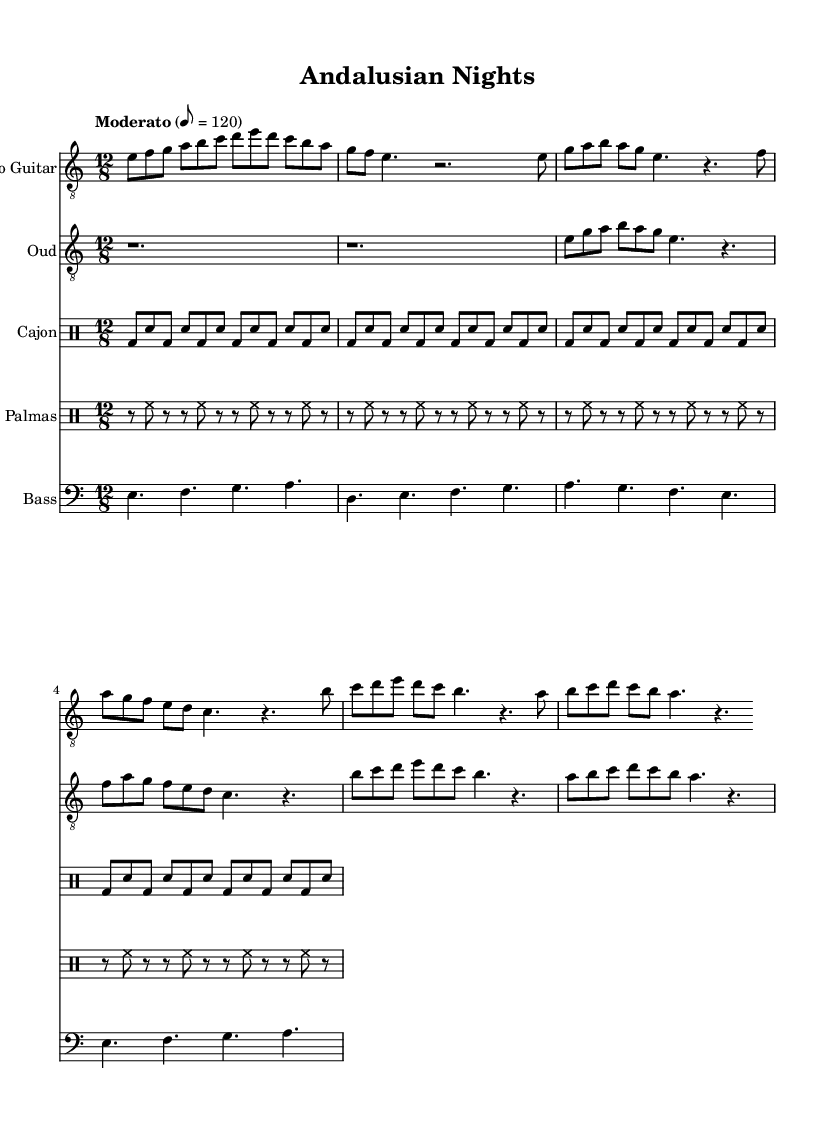What is the key signature of this music? The key signature is E Phrygian, indicated by the notes in the scale that predominantly include E as the tonic and the note information written in the global section. E Phrygian has no sharps or flats.
Answer: E Phrygian What is the time signature of this music? The time signature is indicated as 12/8 in the global section. This means there are 12 eighth notes in each measure.
Answer: 12/8 What is the tempo marking of this music? The tempo is marked as "Moderato" with a metronome mark of 8 = 120, indicating a moderate speed of 120 beats per minute.
Answer: Moderato, 8 = 120 How many measures are present in the flamenco guitar part? The flamenco guitar part contains 6 measures, which can be counted by examining the number of bar lines present in the provided notation.
Answer: 6 measures Which instruments are utilized in this piece? The piece features Flamenco Guitar, Oud, Cajon, Palmas, and Bass, as indicated by the titles of the staves in the score section.
Answer: Flamenco Guitar, Oud, Cajon, Palmas, Bass What style of music does this composition represent? This composition represents Flamenco-inspired world fusion, as indicated by the stylistic elements reflected in the instrumentation and rhythmic patterns, blending Spanish, Arabic, and Latin influences.
Answer: Flamenco-inspired world fusion What is the rhythm pattern of the Cajon part? The Cajon part features a consistent alternating pattern of bass and snare strokes that can be deciphered through the drum notation, reflected in repeated sequences of notes.
Answer: Alternating bass and snare 